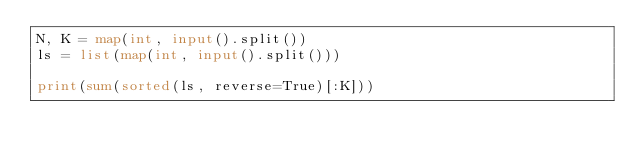Convert code to text. <code><loc_0><loc_0><loc_500><loc_500><_Python_>N, K = map(int, input().split())
ls = list(map(int, input().split()))

print(sum(sorted(ls, reverse=True)[:K]))</code> 